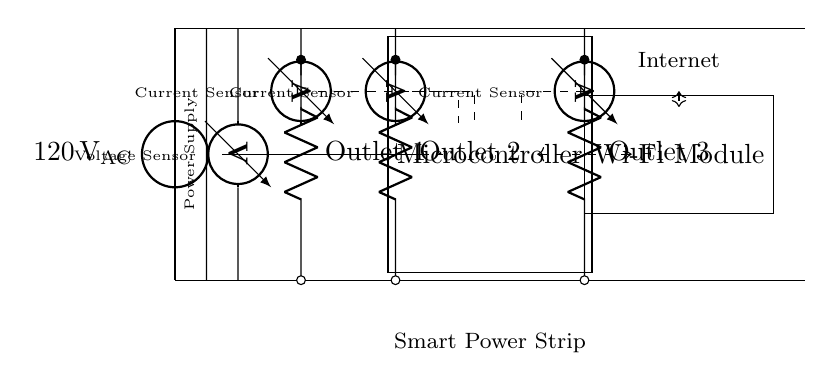What is the main power source voltage? The main power source is indicated by the voltage source symbol in the diagram, which shows it supplying a voltage of 120 volts alternating current (VAC).
Answer: 120 volts AC How many outlets are present in the circuit? By counting the distinct outlet symbols labeled "Outlet 1", "Outlet 2", and "Outlet 3", we find there are three power outlets in total.
Answer: 3 What type of sensors are used for energy monitoring in this circuit? The circuit shows three current sensors and one voltage sensor. Current sensors monitor the flow of current, while the voltage sensor measures voltage.
Answer: Current and voltage sensors How does the microcontroller connect to the Wi-Fi module? The connection is depicted by a dashed double-headed arrow indicating that the microcontroller interfaces with the Wi-Fi module through a communication link. The presence of the dashed line represents a wireless connection.
Answer: Wireless connection What is the purpose of the transformer in this circuit? The transformer is shown as converting the input 120 volts AC to a lower voltage required for powering the microcontroller and Wi-Fi module. This indicates its role in stepping down the voltage from the main supply for safe use.
Answer: Voltage conversion What components allow for remote control of the power strip? The Wi-Fi module enables the communication necessary for remote access, along with the microcontroller that processes commands and controls the power outlets based on the gathered data from the sensors.
Answer: Wi-Fi module and microcontroller 